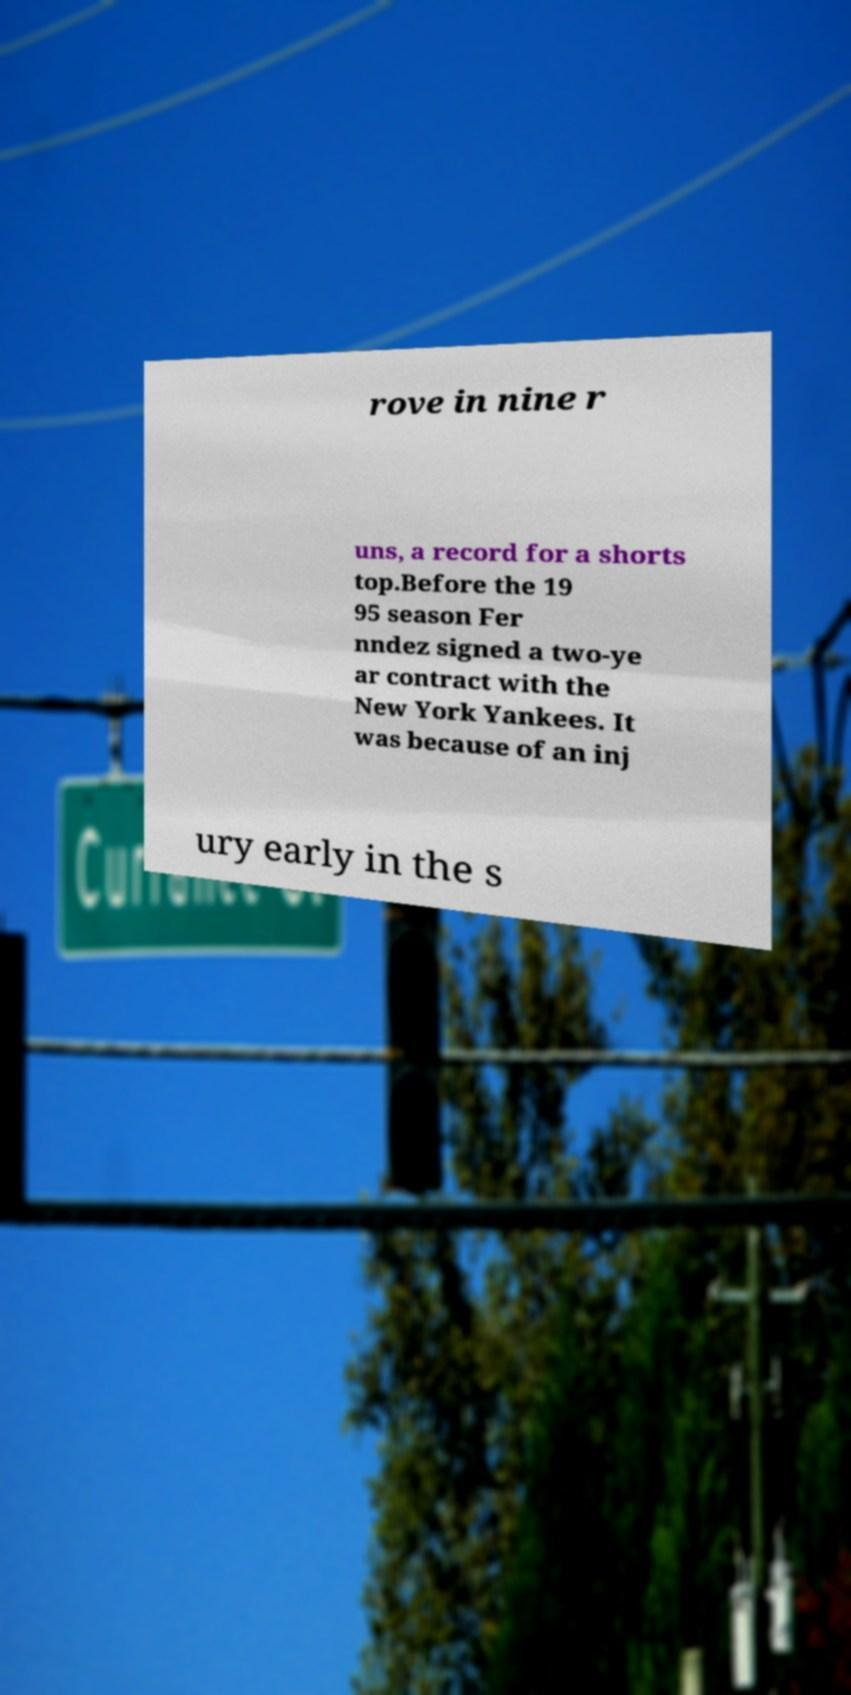For documentation purposes, I need the text within this image transcribed. Could you provide that? rove in nine r uns, a record for a shorts top.Before the 19 95 season Fer nndez signed a two-ye ar contract with the New York Yankees. It was because of an inj ury early in the s 